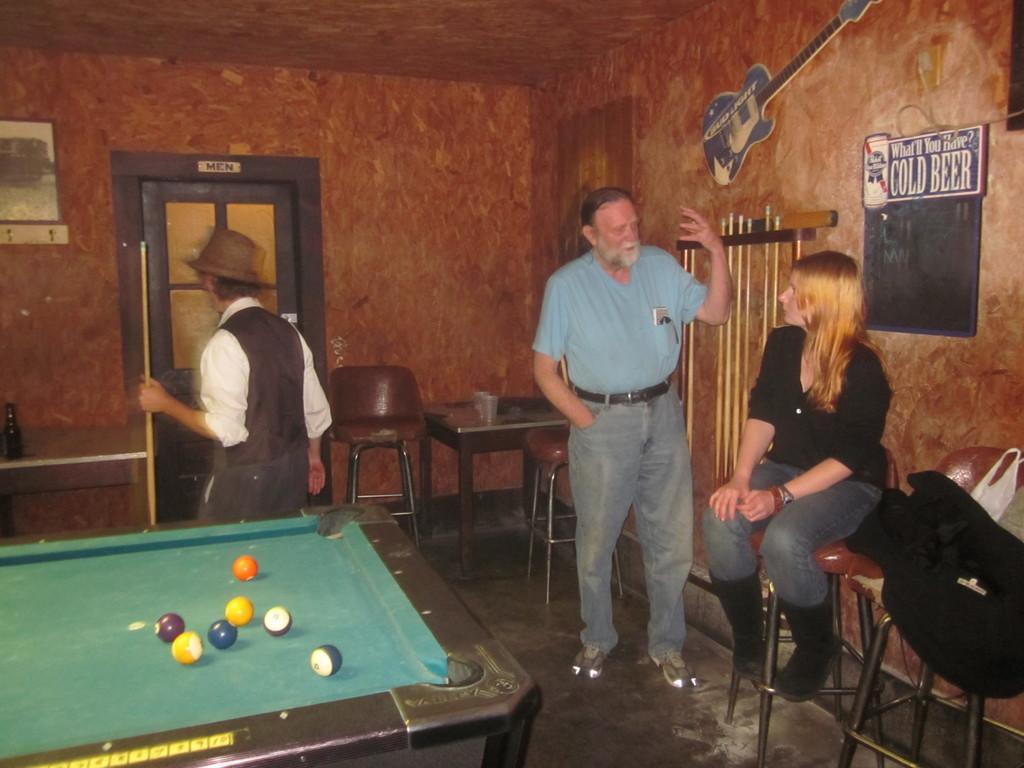Describe this image in one or two sentences. In this picture we can see two men standing and here woman sitting on stool and talking to this man and in front of them we have snookers table and in background we can see door, wall, chairs, table glasses on it, guitar, sticker to wall. 